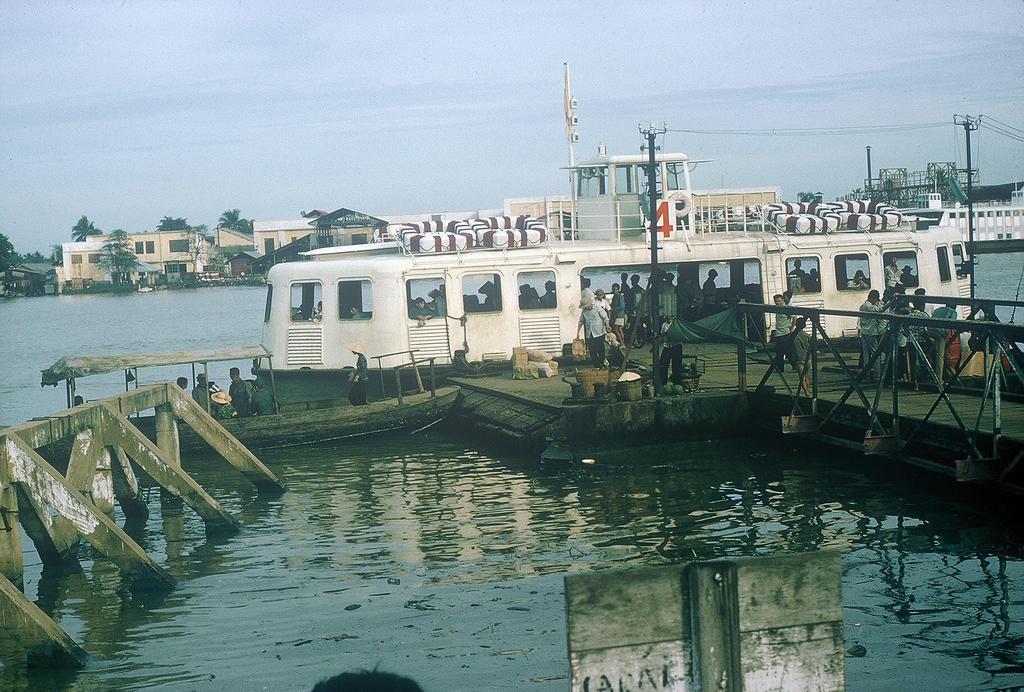In one or two sentences, can you explain what this image depicts? At the bottom of the image there is water. There is a ship. In the background of the image there are buildings. There are trees. At the top of the image there is sky. 